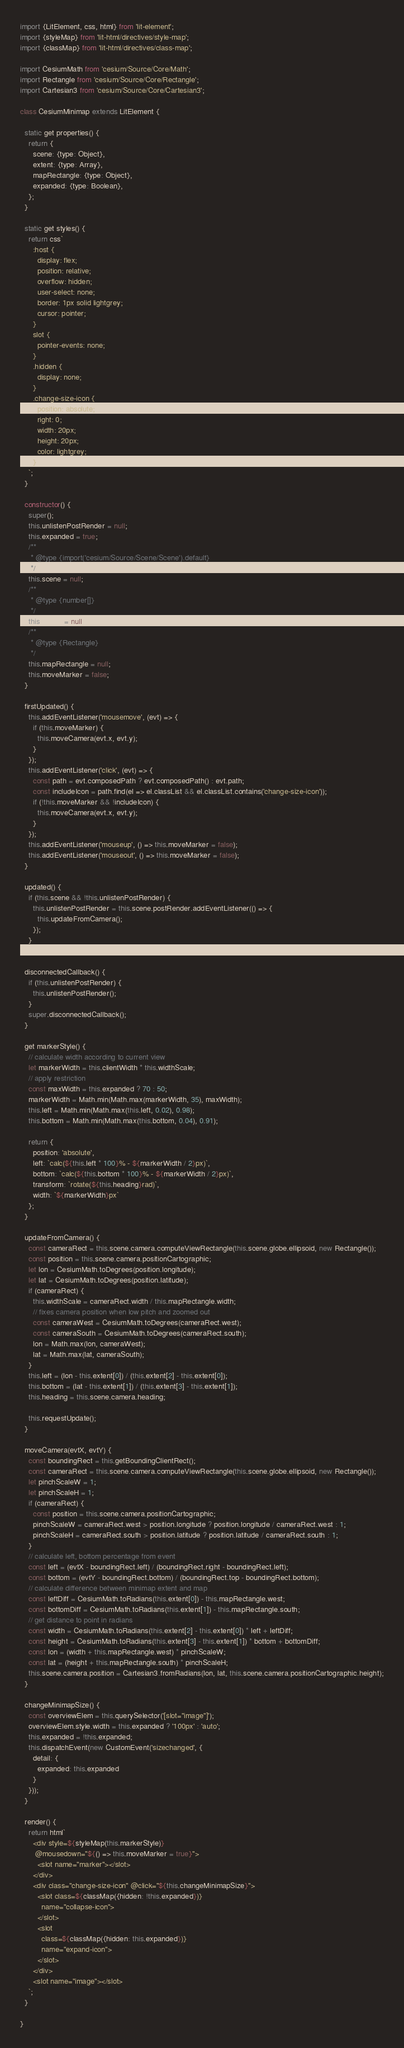Convert code to text. <code><loc_0><loc_0><loc_500><loc_500><_JavaScript_>import {LitElement, css, html} from 'lit-element';
import {styleMap} from 'lit-html/directives/style-map';
import {classMap} from 'lit-html/directives/class-map';

import CesiumMath from 'cesium/Source/Core/Math';
import Rectangle from 'cesium/Source/Core/Rectangle';
import Cartesian3 from 'cesium/Source/Core/Cartesian3';

class CesiumMinimap extends LitElement {

  static get properties() {
    return {
      scene: {type: Object},
      extent: {type: Array},
      mapRectangle: {type: Object},
      expanded: {type: Boolean},
    };
  }

  static get styles() {
    return css`
      :host {
        display: flex;
        position: relative;
        overflow: hidden;
        user-select: none;
        border: 1px solid lightgrey;
        cursor: pointer;
      }
      slot {
        pointer-events: none;
      }
      .hidden {
        display: none;
      }
      .change-size-icon {
        position: absolute;
        right: 0;
        width: 20px;
        height: 20px;
        color: lightgrey;
      }
    `;
  }

  constructor() {
    super();
    this.unlistenPostRender = null;
    this.expanded = true;
    /**
     * @type {import('cesium/Source/Scene/Scene').default}
     */
    this.scene = null;
    /**
     * @type {number[]}
     */
    this.extent = null;
    /**
     * @type {Rectangle}
     */
    this.mapRectangle = null;
    this.moveMarker = false;
  }

  firstUpdated() {
    this.addEventListener('mousemove', (evt) => {
      if (this.moveMarker) {
        this.moveCamera(evt.x, evt.y);
      }
    });
    this.addEventListener('click', (evt) => {
      const path = evt.composedPath ? evt.composedPath() : evt.path;
      const includeIcon = path.find(el => el.classList && el.classList.contains('change-size-icon'));
      if (!this.moveMarker && !includeIcon) {
        this.moveCamera(evt.x, evt.y);
      }
    });
    this.addEventListener('mouseup', () => this.moveMarker = false);
    this.addEventListener('mouseout', () => this.moveMarker = false);
  }

  updated() {
    if (this.scene && !this.unlistenPostRender) {
      this.unlistenPostRender = this.scene.postRender.addEventListener(() => {
        this.updateFromCamera();
      });
    }
  }

  disconnectedCallback() {
    if (this.unlistenPostRender) {
      this.unlistenPostRender();
    }
    super.disconnectedCallback();
  }

  get markerStyle() {
    // calculate width according to current view
    let markerWidth = this.clientWidth * this.widthScale;
    // apply restriction
    const maxWidth = this.expanded ? 70 : 50;
    markerWidth = Math.min(Math.max(markerWidth, 35), maxWidth);
    this.left = Math.min(Math.max(this.left, 0.02), 0.98);
    this.bottom = Math.min(Math.max(this.bottom, 0.04), 0.91);

    return {
      position: 'absolute',
      left: `calc(${this.left * 100}% - ${markerWidth / 2}px)`,
      bottom: `calc(${this.bottom * 100}% - ${markerWidth / 2}px)`,
      transform: `rotate(${this.heading}rad)`,
      width: `${markerWidth}px`
    };
  }

  updateFromCamera() {
    const cameraRect = this.scene.camera.computeViewRectangle(this.scene.globe.ellipsoid, new Rectangle());
    const position = this.scene.camera.positionCartographic;
    let lon = CesiumMath.toDegrees(position.longitude);
    let lat = CesiumMath.toDegrees(position.latitude);
    if (cameraRect) {
      this.widthScale = cameraRect.width / this.mapRectangle.width;
      // fixes camera position when low pitch and zoomed out
      const cameraWest = CesiumMath.toDegrees(cameraRect.west);
      const cameraSouth = CesiumMath.toDegrees(cameraRect.south);
      lon = Math.max(lon, cameraWest);
      lat = Math.max(lat, cameraSouth);
    }
    this.left = (lon - this.extent[0]) / (this.extent[2] - this.extent[0]);
    this.bottom = (lat - this.extent[1]) / (this.extent[3] - this.extent[1]);
    this.heading = this.scene.camera.heading;

    this.requestUpdate();
  }

  moveCamera(evtX, evtY) {
    const boundingRect = this.getBoundingClientRect();
    const cameraRect = this.scene.camera.computeViewRectangle(this.scene.globe.ellipsoid, new Rectangle());
    let pinchScaleW = 1;
    let pinchScaleH = 1;
    if (cameraRect) {
      const position = this.scene.camera.positionCartographic;
      pinchScaleW = cameraRect.west > position.longitude ? position.longitude / cameraRect.west : 1;
      pinchScaleH = cameraRect.south > position.latitude ? position.latitude / cameraRect.south : 1;
    }
    // calculate left, bottom percentage from event
    const left = (evtX - boundingRect.left) / (boundingRect.right - boundingRect.left);
    const bottom = (evtY - boundingRect.bottom) / (boundingRect.top - boundingRect.bottom);
    // calculate difference between minimap extent and map
    const leftDiff = CesiumMath.toRadians(this.extent[0]) - this.mapRectangle.west;
    const bottomDiff = CesiumMath.toRadians(this.extent[1]) - this.mapRectangle.south;
    // get distance to point in radians
    const width = CesiumMath.toRadians(this.extent[2] - this.extent[0]) * left + leftDiff;
    const height = CesiumMath.toRadians(this.extent[3] - this.extent[1]) * bottom + bottomDiff;
    const lon = (width + this.mapRectangle.west) * pinchScaleW;
    const lat = (height + this.mapRectangle.south) * pinchScaleH;
    this.scene.camera.position = Cartesian3.fromRadians(lon, lat, this.scene.camera.positionCartographic.height);
  }

  changeMinimapSize() {
    const overviewElem = this.querySelector('[slot="image"]');
    overviewElem.style.width = this.expanded ? '100px' : 'auto';
    this.expanded = !this.expanded;
    this.dispatchEvent(new CustomEvent('sizechanged', {
      detail: {
        expanded: this.expanded
      }
    }));
  }

  render() {
    return html`
      <div style=${styleMap(this.markerStyle)}
       @mousedown="${() => this.moveMarker = true}">
        <slot name="marker"></slot>
      </div>
      <div class="change-size-icon" @click="${this.changeMinimapSize}">
        <slot class=${classMap({hidden: !this.expanded})}
          name="collapse-icon">
        </slot>
        <slot
          class=${classMap({hidden: this.expanded})}
          name="expand-icon">
        </slot>
      </div>
      <slot name="image"></slot>
    `;
  }

}
</code> 